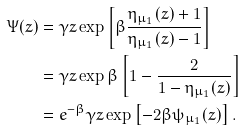<formula> <loc_0><loc_0><loc_500><loc_500>\Psi ( z ) & = \gamma z \exp \left [ \beta \frac { \eta _ { \mu _ { 1 } } ( z ) + 1 } { \eta _ { \mu _ { 1 } } ( z ) - 1 } \right ] \\ & = \gamma z \exp \beta \left [ 1 - \frac { 2 } { 1 - \eta _ { \mu _ { 1 } } ( z ) } \right ] \\ & = e ^ { - \beta } \gamma z \exp \left [ - 2 \beta \psi _ { \mu _ { 1 } } ( z ) \right ] .</formula> 